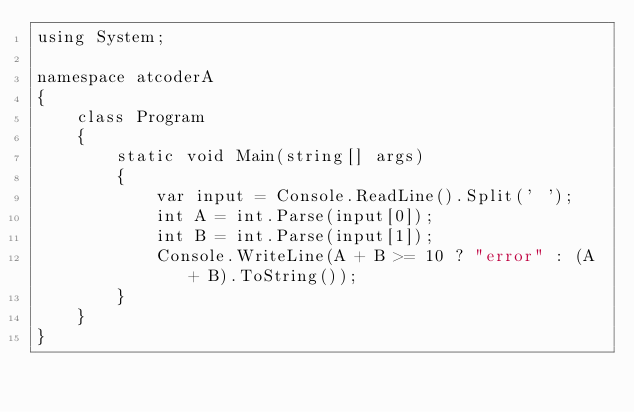<code> <loc_0><loc_0><loc_500><loc_500><_C#_>using System;

namespace atcoderA
{
    class Program
    {
        static void Main(string[] args)
        {
            var input = Console.ReadLine().Split(' ');
            int A = int.Parse(input[0]);
            int B = int.Parse(input[1]);
            Console.WriteLine(A + B >= 10 ? "error" : (A + B).ToString());
        }
    }
}</code> 